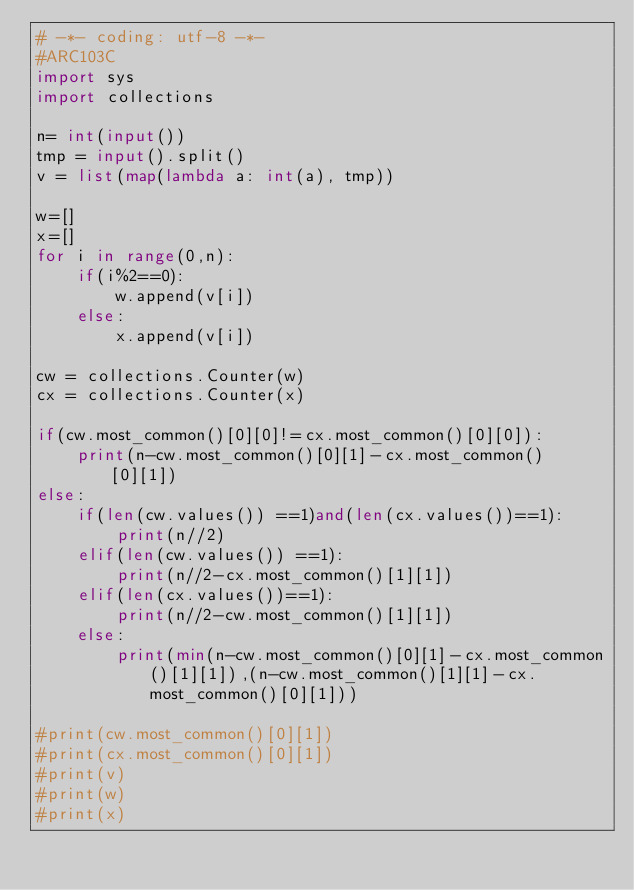Convert code to text. <code><loc_0><loc_0><loc_500><loc_500><_Python_># -*- coding: utf-8 -*-
#ARC103C
import sys
import collections

n= int(input())
tmp = input().split()
v = list(map(lambda a: int(a), tmp))

w=[]
x=[]
for i in range(0,n):
	if(i%2==0):
		w.append(v[i])
	else:
		x.append(v[i])

cw = collections.Counter(w)
cx = collections.Counter(x)

if(cw.most_common()[0][0]!=cx.most_common()[0][0]):
	print(n-cw.most_common()[0][1]-cx.most_common()[0][1])
else:
	if(len(cw.values()) ==1)and(len(cx.values())==1):
		print(n//2)
	elif(len(cw.values()) ==1):
		print(n//2-cx.most_common()[1][1])
	elif(len(cx.values())==1):
		print(n//2-cw.most_common()[1][1])
	else:
		print(min(n-cw.most_common()[0][1]-cx.most_common()[1][1]),(n-cw.most_common()[1][1]-cx.most_common()[0][1]))

#print(cw.most_common()[0][1])
#print(cx.most_common()[0][1])
#print(v)
#print(w)
#print(x)

</code> 